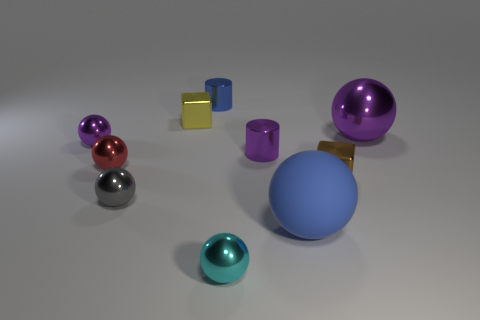Is the gray thing the same shape as the matte thing?
Your answer should be very brief. Yes. Is there any other thing that has the same material as the large blue ball?
Make the answer very short. No. Is the size of the purple metallic thing that is left of the gray sphere the same as the yellow block that is behind the brown shiny cube?
Make the answer very short. Yes. The ball that is both on the right side of the small red ball and behind the brown metal thing is made of what material?
Your answer should be compact. Metal. Are there any other things that are the same color as the big shiny object?
Offer a very short reply. Yes. Are there fewer big blue rubber balls that are in front of the tiny brown block than tiny gray metal things?
Your answer should be compact. No. Are there more brown metal things than cubes?
Give a very brief answer. No. There is a purple metallic thing that is to the left of the tiny block that is left of the tiny blue object; is there a small object that is to the right of it?
Your answer should be compact. Yes. What number of other things are the same size as the purple shiny cylinder?
Provide a short and direct response. 7. There is a small purple cylinder; are there any yellow cubes to the right of it?
Your response must be concise. No. 